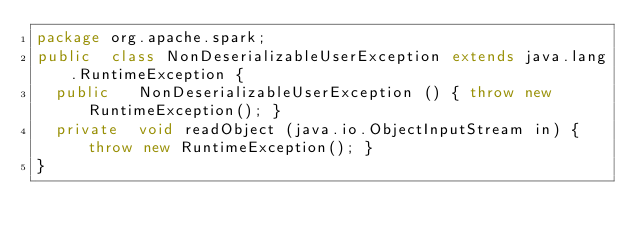Convert code to text. <code><loc_0><loc_0><loc_500><loc_500><_Java_>package org.apache.spark;
public  class NonDeserializableUserException extends java.lang.RuntimeException {
  public   NonDeserializableUserException () { throw new RuntimeException(); }
  private  void readObject (java.io.ObjectInputStream in) { throw new RuntimeException(); }
}
</code> 